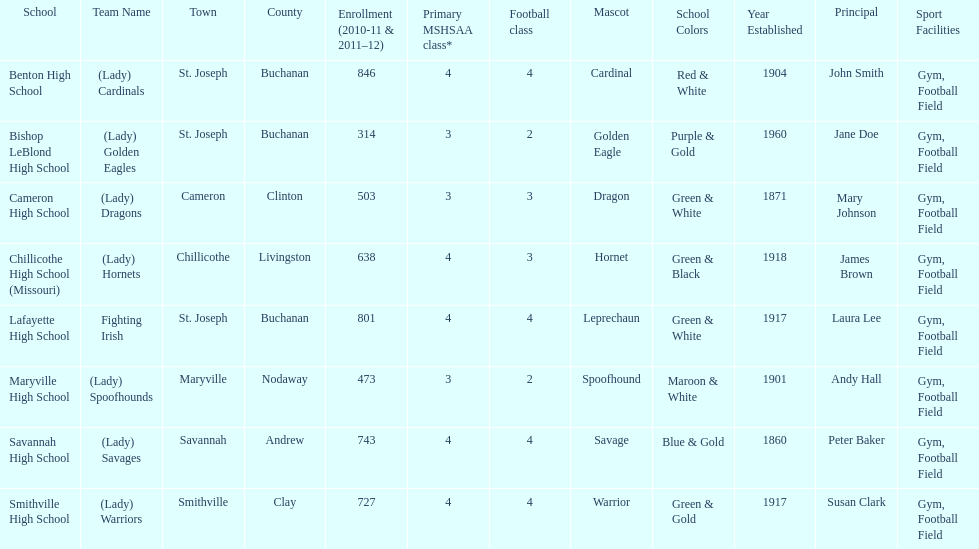Which school has the largest enrollment? Benton High School. 